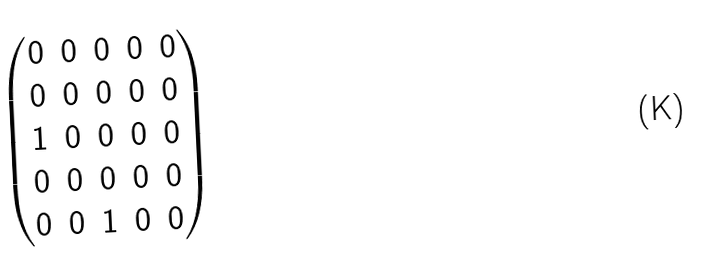Convert formula to latex. <formula><loc_0><loc_0><loc_500><loc_500>\begin{pmatrix} 0 & 0 & 0 & 0 & 0 \\ 0 & 0 & 0 & 0 & 0 \\ 1 & 0 & 0 & 0 & 0 \\ 0 & 0 & 0 & 0 & 0 \\ 0 & 0 & 1 & 0 & 0 \\ \end{pmatrix}</formula> 